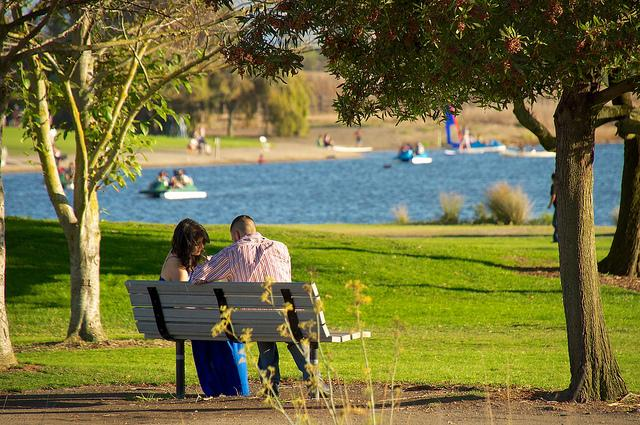What is rented for family enjoyment? Please explain your reasoning. boats. The boats can be rented for the day. 